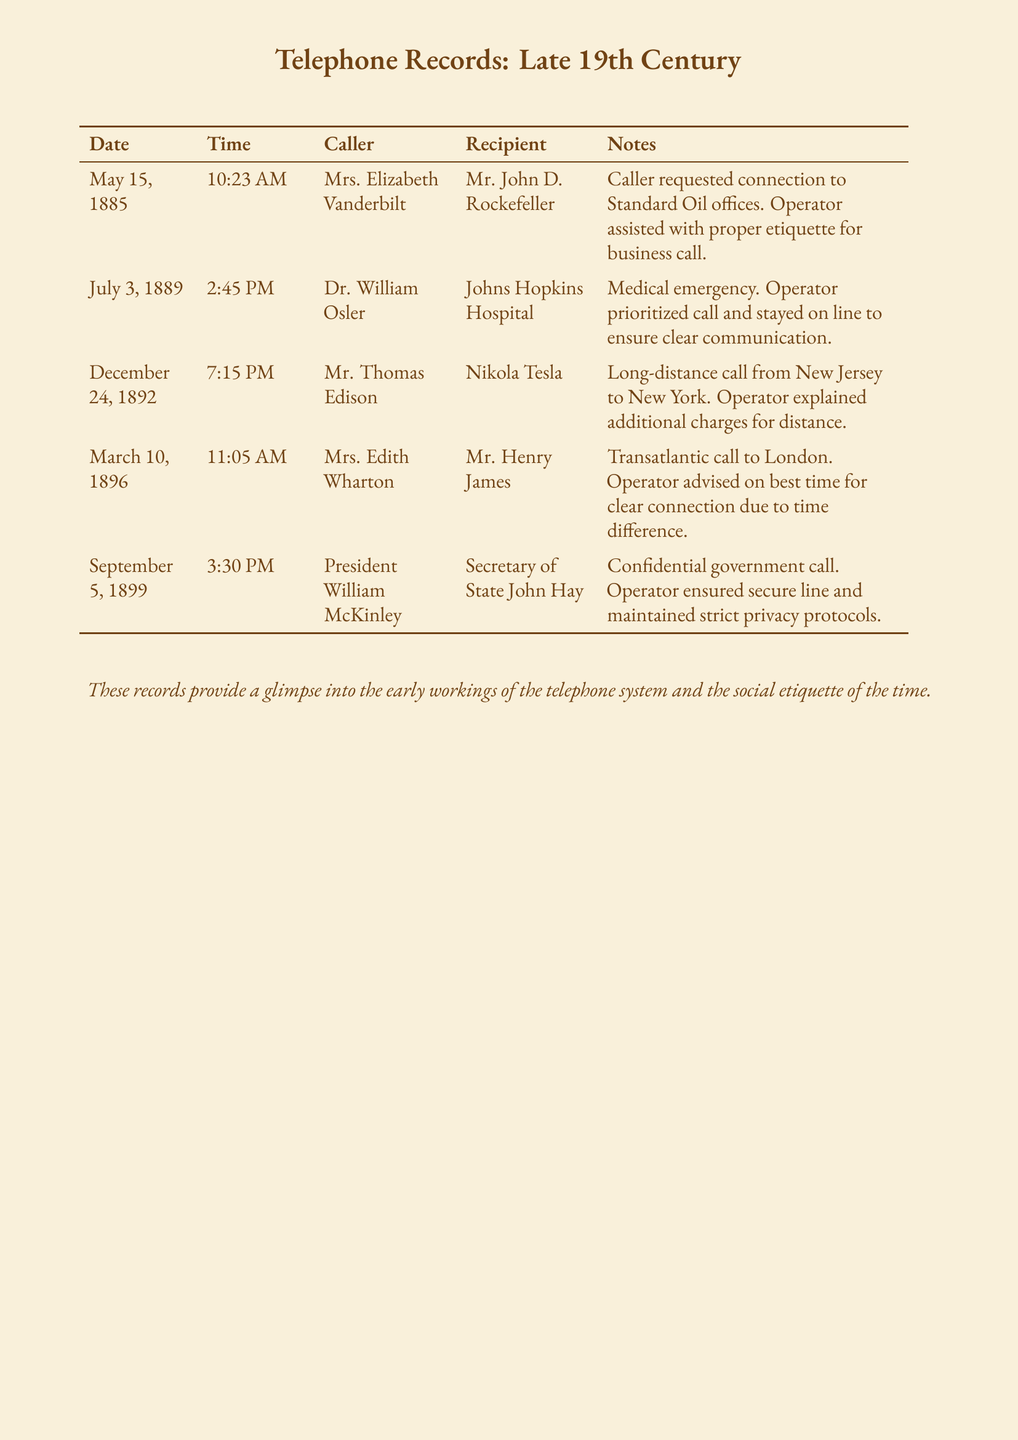What is the date of the call between Mrs. Elizabeth Vanderbilt and Mr. John D. Rockefeller? The document specifies that this call took place on May 15, 1885.
Answer: May 15, 1885 Who was the caller in the medical emergency on July 3, 1889? The caller for the medical emergency was Dr. William Osler.
Answer: Dr. William Osler What time was Mr. Thomas Edison’s call to Nikola Tesla? The time noted for Mr. Edison’s call was 7:15 PM.
Answer: 7:15 PM How many calls are recorded in the document? By counting the entries in the table, there are five calls documented.
Answer: Five Which operator practice is noted in the call from Mrs. Edith Wharton to Mr. Henry James? The operator advised on the best time for a clear connection due to time difference.
Answer: Advised on best time What was the recipient's name in the call made by President William McKinley? The recipient of President McKinley's call was Secretary of State John Hay.
Answer: Secretary of State John Hay What was a common practice by operators noted in these records? Operators assisted with proper etiquette for calls, ensuring courteous communication.
Answer: Proper etiquette Was the call from Mr. Edison to Mr. Tesla a long-distance call? Yes, it was specified as a long-distance call from New Jersey to New York.
Answer: Yes 